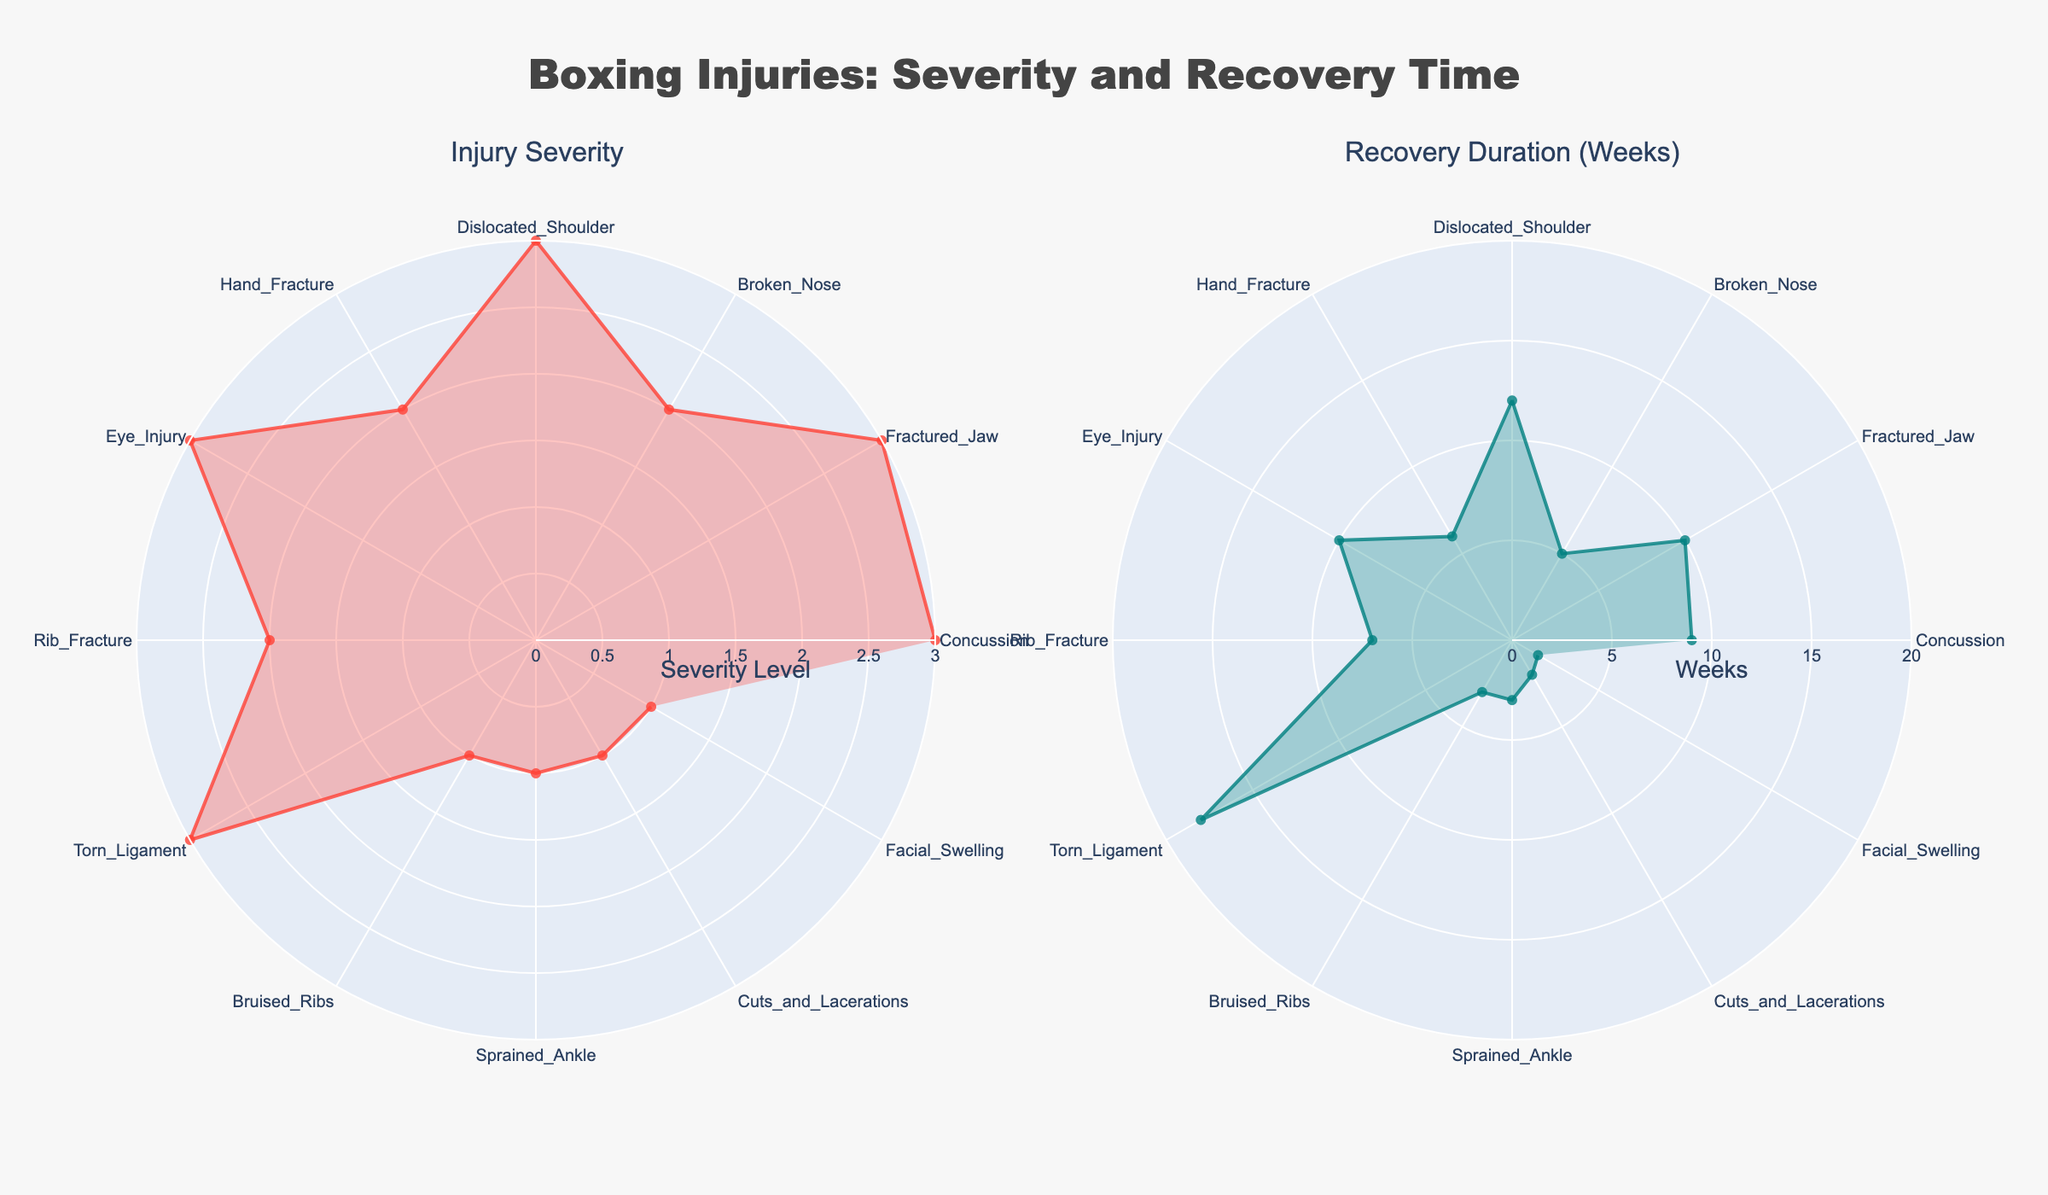How many injuries are classified as "High" severity? By looking at the "Injury Severity" radar chart, count the types of injuries listed with the highest severity level (represented at the outermost circle).
Answer: 5 Which injury type has the longest average recovery duration? Refer to the "Recovery Duration (Weeks)" radar chart and find the type of injury that reaches furthest towards the outer edge of the chart, indicating the longest recovery duration.
Answer: Torn Ligament Compare the recovery durations of a "Broken Nose" and "Hand Fracture". Which one has a longer recovery period? On the "Recovery Duration (Weeks)" radar chart, locate "Broken Nose" and "Hand Fracture", and compare the radial values (lengths from the center) for each.
Answer: Hand Fracture What is the total number of injury types displayed in the charts? Count the number of distinct labels around the radar charts, which represent different injury types.
Answer: 12 Identify an injury type with a "Low" severity level and a recovery duration of fewer than 4 weeks. Look at the "Injury Severity" radar chart for labels close to the innermost circle of low severity and cross-reference them with the "Recovery Duration" chart.
Answer: Facial Swelling How does the severity of "Rib Fracture" compare to "Eye Injury"? On the "Injury Severity" radar chart, find the radial value for each injury and compare them; the one closer to the outermost circle is more severe.
Answer: Eye Injury is more severe Which injury types have the same severity level but different recovery durations? Identify injury types on the "Injury Severity" chart with the same radial value, then cross-reference with the "Recovery Duration" chart for differences in radial lengths.
Answer: Fractured Jaw and Eye Injury If a boxer gets a "Sprained Ankle", what is the expected recovery duration? Refer to the "Recovery Duration (Weeks)" radar chart and locate the radial length corresponding to "Sprained Ankle".
Answer: 3 weeks Does "Bruised Ribs" have a longer or shorter recovery duration compared to "Cuts and Lacerations"? In the "Recovery Duration (Weeks)" radar chart, compare the radial values for "Bruised Ribs" and "Cuts and Lacerations".
Answer: Longer Are there more injury types classified as "Medium" or "Low" severity? Count the labels in each respective section (Medium and Low) of the "Injury Severity" radar chart and compare quantities.
Answer: Low 